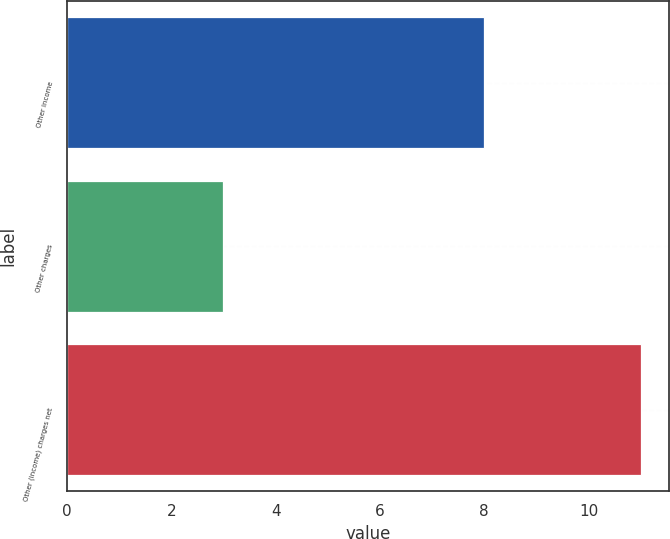Convert chart to OTSL. <chart><loc_0><loc_0><loc_500><loc_500><bar_chart><fcel>Other income<fcel>Other charges<fcel>Other (income) charges net<nl><fcel>8<fcel>3<fcel>11<nl></chart> 